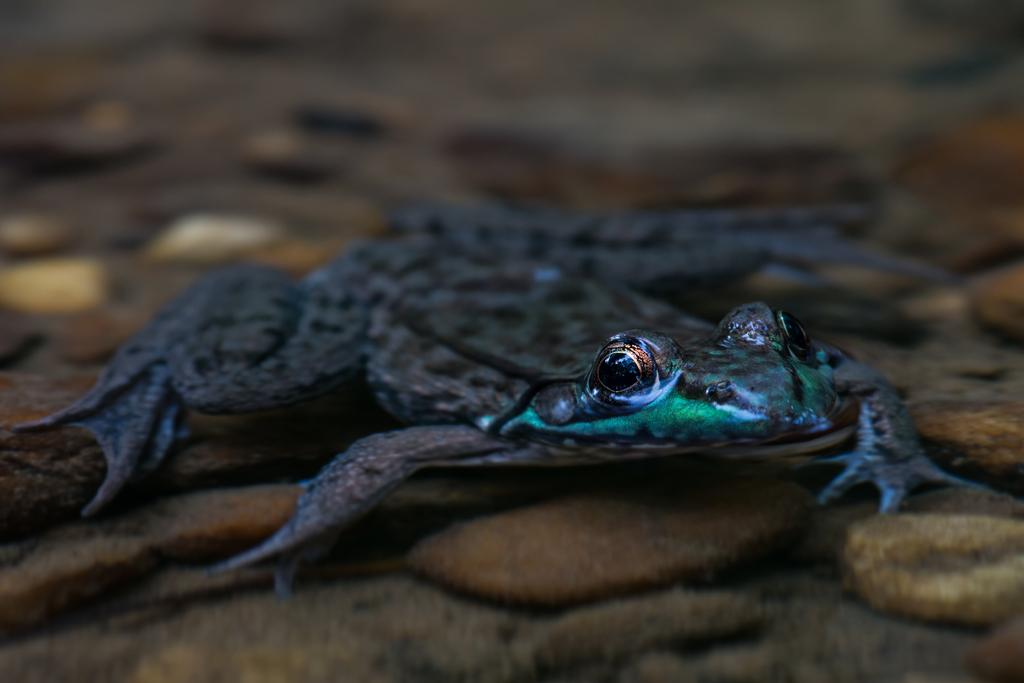What is the main subject in the center of the image? There is a frog in the center of the image. What can be seen at the bottom of the image? There are stones at the bottom of the image. What type of honey is the frog collecting from the stones in the image? There is no honey present in the image, and the frog is not collecting anything from the stones. 